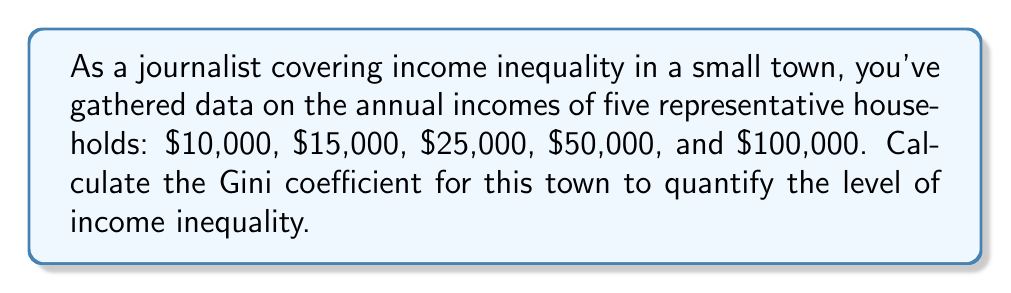Teach me how to tackle this problem. To calculate the Gini coefficient, we'll follow these steps:

1. Order the incomes from lowest to highest:
   $10,000, $15,000, $25,000, $50,000, $100,000

2. Calculate the cumulative share of the population (x) and the cumulative share of income (y):
   
   x: 0.2, 0.4, 0.6, 0.8, 1.0
   y: 0.05, 0.125, 0.25, 0.5, 1.0

3. Calculate the area under the Lorenz curve (B) using the trapezoidal rule:
   
   $$B = \frac{1}{2} \sum_{i=1}^{n} (x_i - x_{i-1})(y_i + y_{i-1})$$
   
   $$B = \frac{1}{2}[(0.2-0)(0.05+0) + (0.4-0.2)(0.125+0.05) + (0.6-0.4)(0.25+0.125) + (0.8-0.6)(0.5+0.25) + (1.0-0.8)(1.0+0.5)]$$
   
   $$B = \frac{1}{2}[0.01 + 0.035 + 0.075 + 0.15 + 0.3] = 0.285$$

4. Calculate the area of perfect equality (A), which is always 0.5:
   
   $$A = \frac{1}{2}$$

5. Calculate the Gini coefficient (G) using the formula:
   
   $$G = \frac{A - B}{A} = \frac{0.5 - 0.285}{0.5} = 0.43$$
Answer: 0.43 